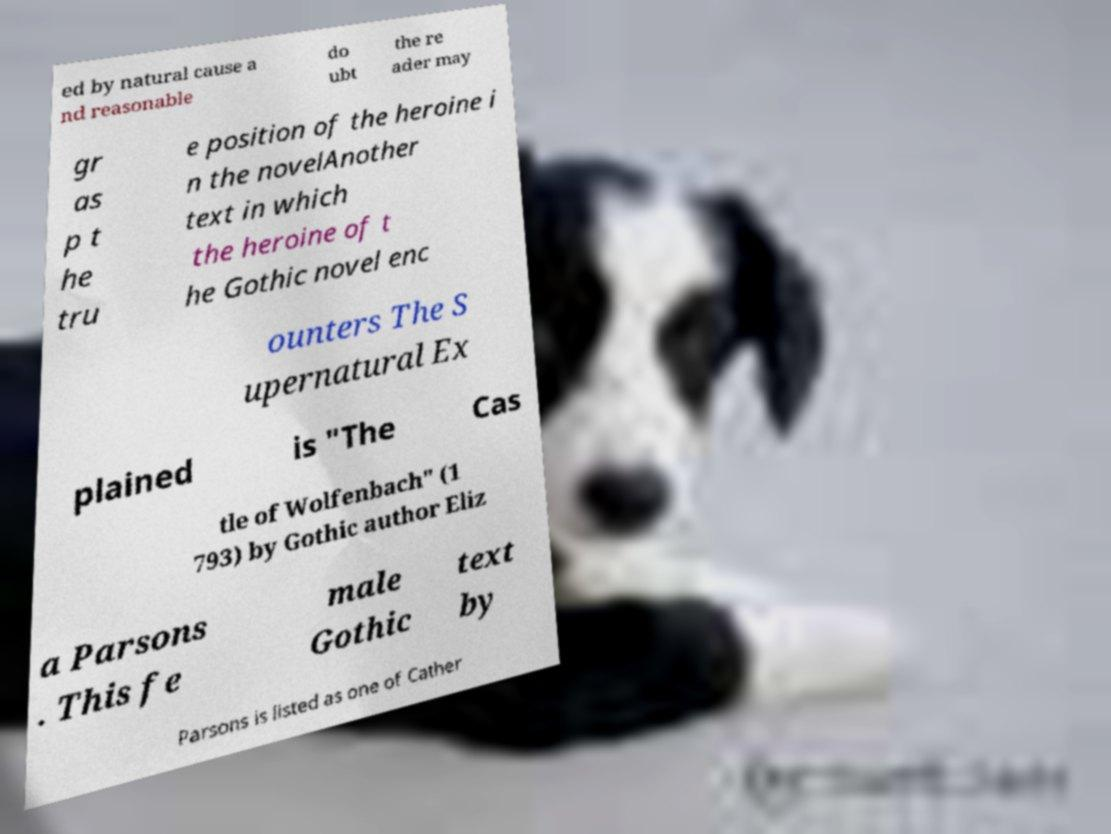Can you read and provide the text displayed in the image?This photo seems to have some interesting text. Can you extract and type it out for me? ed by natural cause a nd reasonable do ubt the re ader may gr as p t he tru e position of the heroine i n the novelAnother text in which the heroine of t he Gothic novel enc ounters The S upernatural Ex plained is "The Cas tle of Wolfenbach" (1 793) by Gothic author Eliz a Parsons . This fe male Gothic text by Parsons is listed as one of Cather 